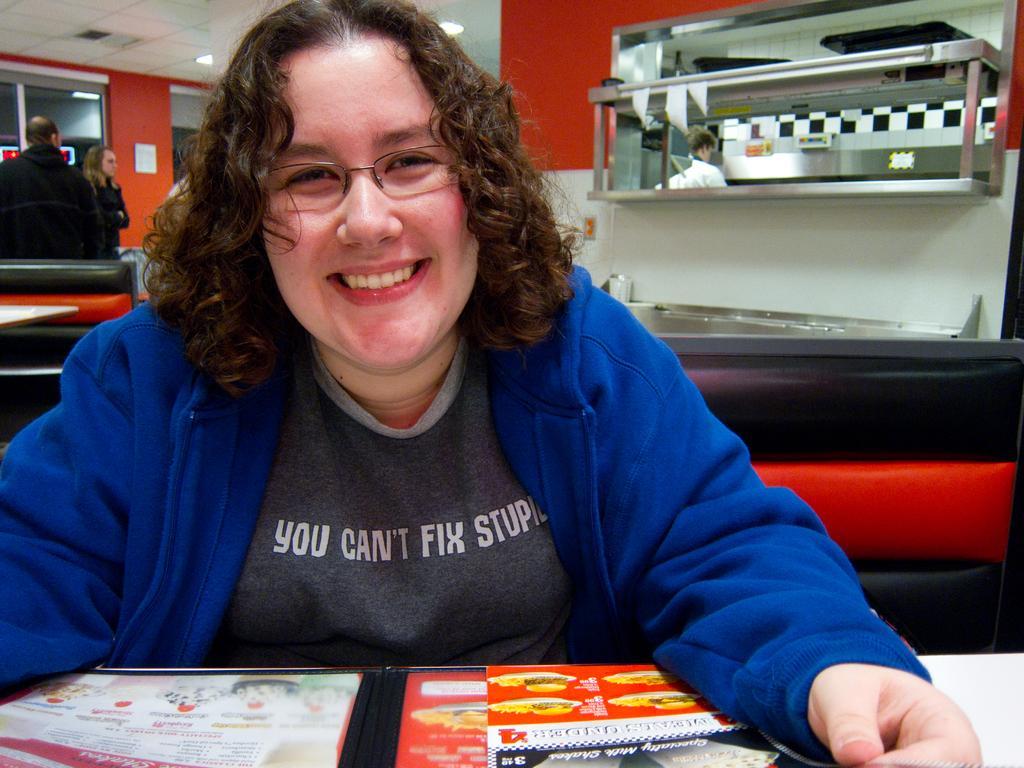In one or two sentences, can you explain what this image depicts? In this image we can see few people, a person sitting on the couch, there is an object looks like a menu card on the table, there is a metal object to the wall and there are few objects on it and lights to the ceiling in the background. 